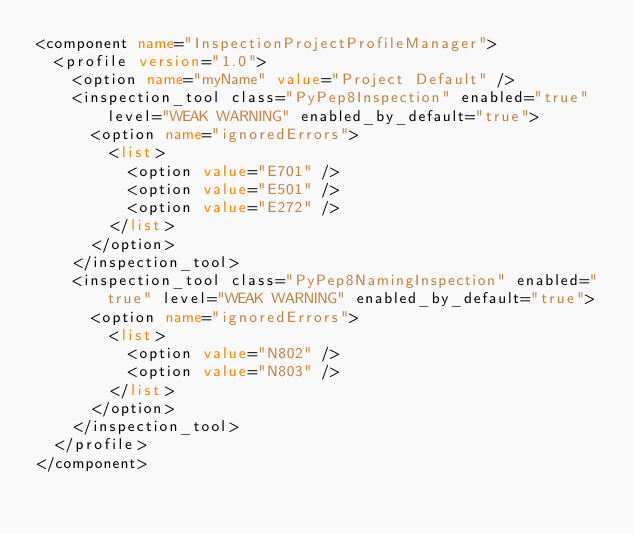Convert code to text. <code><loc_0><loc_0><loc_500><loc_500><_XML_><component name="InspectionProjectProfileManager">
  <profile version="1.0">
    <option name="myName" value="Project Default" />
    <inspection_tool class="PyPep8Inspection" enabled="true" level="WEAK WARNING" enabled_by_default="true">
      <option name="ignoredErrors">
        <list>
          <option value="E701" />
          <option value="E501" />
          <option value="E272" />
        </list>
      </option>
    </inspection_tool>
    <inspection_tool class="PyPep8NamingInspection" enabled="true" level="WEAK WARNING" enabled_by_default="true">
      <option name="ignoredErrors">
        <list>
          <option value="N802" />
          <option value="N803" />
        </list>
      </option>
    </inspection_tool>
  </profile>
</component></code> 